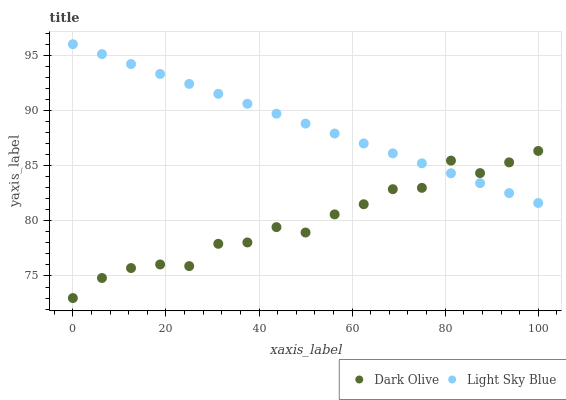Does Dark Olive have the minimum area under the curve?
Answer yes or no. Yes. Does Light Sky Blue have the maximum area under the curve?
Answer yes or no. Yes. Does Light Sky Blue have the minimum area under the curve?
Answer yes or no. No. Is Light Sky Blue the smoothest?
Answer yes or no. Yes. Is Dark Olive the roughest?
Answer yes or no. Yes. Is Light Sky Blue the roughest?
Answer yes or no. No. Does Dark Olive have the lowest value?
Answer yes or no. Yes. Does Light Sky Blue have the lowest value?
Answer yes or no. No. Does Light Sky Blue have the highest value?
Answer yes or no. Yes. Does Light Sky Blue intersect Dark Olive?
Answer yes or no. Yes. Is Light Sky Blue less than Dark Olive?
Answer yes or no. No. Is Light Sky Blue greater than Dark Olive?
Answer yes or no. No. 